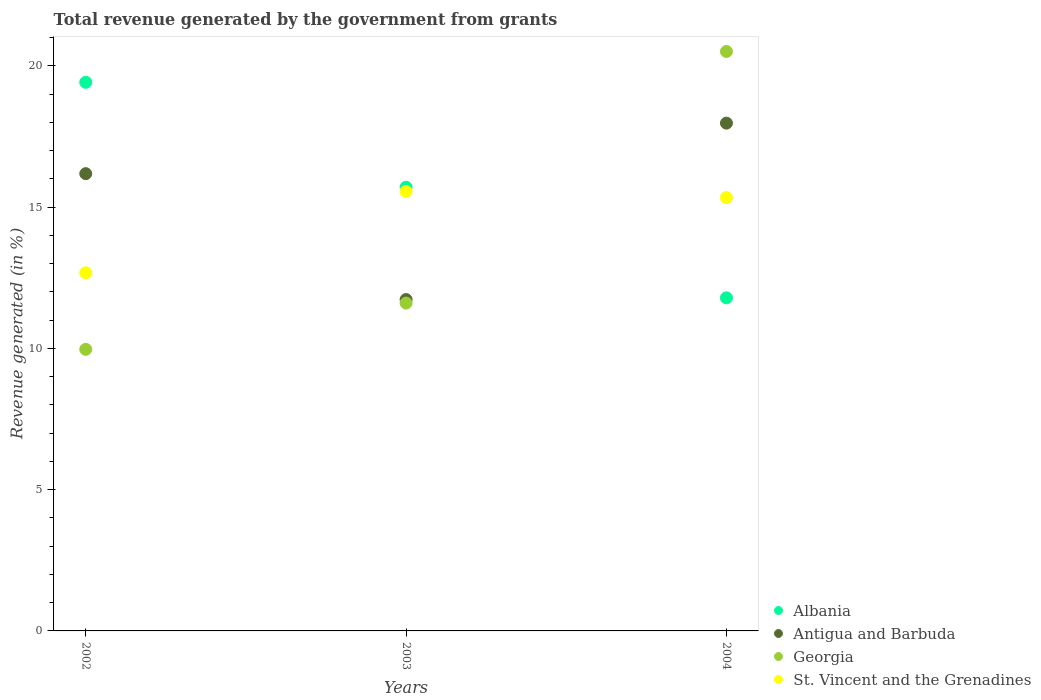How many different coloured dotlines are there?
Provide a short and direct response. 4. What is the total revenue generated in St. Vincent and the Grenadines in 2002?
Provide a short and direct response. 12.68. Across all years, what is the maximum total revenue generated in Antigua and Barbuda?
Your response must be concise. 17.97. Across all years, what is the minimum total revenue generated in St. Vincent and the Grenadines?
Offer a very short reply. 12.68. What is the total total revenue generated in Antigua and Barbuda in the graph?
Your response must be concise. 45.88. What is the difference between the total revenue generated in Albania in 2003 and that in 2004?
Keep it short and to the point. 3.91. What is the difference between the total revenue generated in Albania in 2004 and the total revenue generated in St. Vincent and the Grenadines in 2002?
Keep it short and to the point. -0.89. What is the average total revenue generated in St. Vincent and the Grenadines per year?
Offer a terse response. 14.52. In the year 2004, what is the difference between the total revenue generated in Georgia and total revenue generated in Antigua and Barbuda?
Offer a terse response. 2.54. What is the ratio of the total revenue generated in Georgia in 2002 to that in 2003?
Your answer should be very brief. 0.86. Is the difference between the total revenue generated in Georgia in 2003 and 2004 greater than the difference between the total revenue generated in Antigua and Barbuda in 2003 and 2004?
Keep it short and to the point. No. What is the difference between the highest and the second highest total revenue generated in Antigua and Barbuda?
Your answer should be very brief. 1.79. What is the difference between the highest and the lowest total revenue generated in St. Vincent and the Grenadines?
Offer a terse response. 2.88. Is the sum of the total revenue generated in Albania in 2003 and 2004 greater than the maximum total revenue generated in Antigua and Barbuda across all years?
Make the answer very short. Yes. Is it the case that in every year, the sum of the total revenue generated in Antigua and Barbuda and total revenue generated in St. Vincent and the Grenadines  is greater than the sum of total revenue generated in Georgia and total revenue generated in Albania?
Offer a terse response. No. Is it the case that in every year, the sum of the total revenue generated in St. Vincent and the Grenadines and total revenue generated in Antigua and Barbuda  is greater than the total revenue generated in Albania?
Make the answer very short. Yes. Does the total revenue generated in St. Vincent and the Grenadines monotonically increase over the years?
Provide a succinct answer. No. How many years are there in the graph?
Your answer should be compact. 3. What is the difference between two consecutive major ticks on the Y-axis?
Provide a succinct answer. 5. Are the values on the major ticks of Y-axis written in scientific E-notation?
Offer a terse response. No. Where does the legend appear in the graph?
Keep it short and to the point. Bottom right. How many legend labels are there?
Your answer should be compact. 4. How are the legend labels stacked?
Provide a short and direct response. Vertical. What is the title of the graph?
Your answer should be very brief. Total revenue generated by the government from grants. Does "Syrian Arab Republic" appear as one of the legend labels in the graph?
Give a very brief answer. No. What is the label or title of the X-axis?
Keep it short and to the point. Years. What is the label or title of the Y-axis?
Provide a short and direct response. Revenue generated (in %). What is the Revenue generated (in %) of Albania in 2002?
Offer a very short reply. 19.42. What is the Revenue generated (in %) of Antigua and Barbuda in 2002?
Offer a terse response. 16.18. What is the Revenue generated (in %) of Georgia in 2002?
Provide a short and direct response. 9.97. What is the Revenue generated (in %) of St. Vincent and the Grenadines in 2002?
Your answer should be compact. 12.68. What is the Revenue generated (in %) in Albania in 2003?
Provide a short and direct response. 15.7. What is the Revenue generated (in %) in Antigua and Barbuda in 2003?
Offer a terse response. 11.73. What is the Revenue generated (in %) in Georgia in 2003?
Give a very brief answer. 11.6. What is the Revenue generated (in %) of St. Vincent and the Grenadines in 2003?
Give a very brief answer. 15.56. What is the Revenue generated (in %) of Albania in 2004?
Make the answer very short. 11.79. What is the Revenue generated (in %) in Antigua and Barbuda in 2004?
Give a very brief answer. 17.97. What is the Revenue generated (in %) in Georgia in 2004?
Offer a terse response. 20.51. What is the Revenue generated (in %) in St. Vincent and the Grenadines in 2004?
Provide a short and direct response. 15.34. Across all years, what is the maximum Revenue generated (in %) in Albania?
Give a very brief answer. 19.42. Across all years, what is the maximum Revenue generated (in %) in Antigua and Barbuda?
Ensure brevity in your answer.  17.97. Across all years, what is the maximum Revenue generated (in %) in Georgia?
Provide a short and direct response. 20.51. Across all years, what is the maximum Revenue generated (in %) in St. Vincent and the Grenadines?
Offer a very short reply. 15.56. Across all years, what is the minimum Revenue generated (in %) of Albania?
Give a very brief answer. 11.79. Across all years, what is the minimum Revenue generated (in %) of Antigua and Barbuda?
Offer a terse response. 11.73. Across all years, what is the minimum Revenue generated (in %) in Georgia?
Offer a terse response. 9.97. Across all years, what is the minimum Revenue generated (in %) of St. Vincent and the Grenadines?
Your answer should be very brief. 12.68. What is the total Revenue generated (in %) of Albania in the graph?
Your answer should be very brief. 46.91. What is the total Revenue generated (in %) in Antigua and Barbuda in the graph?
Ensure brevity in your answer.  45.88. What is the total Revenue generated (in %) of Georgia in the graph?
Ensure brevity in your answer.  42.08. What is the total Revenue generated (in %) in St. Vincent and the Grenadines in the graph?
Give a very brief answer. 43.57. What is the difference between the Revenue generated (in %) of Albania in 2002 and that in 2003?
Keep it short and to the point. 3.72. What is the difference between the Revenue generated (in %) of Antigua and Barbuda in 2002 and that in 2003?
Give a very brief answer. 4.46. What is the difference between the Revenue generated (in %) in Georgia in 2002 and that in 2003?
Ensure brevity in your answer.  -1.64. What is the difference between the Revenue generated (in %) in St. Vincent and the Grenadines in 2002 and that in 2003?
Offer a very short reply. -2.88. What is the difference between the Revenue generated (in %) in Albania in 2002 and that in 2004?
Provide a short and direct response. 7.63. What is the difference between the Revenue generated (in %) in Antigua and Barbuda in 2002 and that in 2004?
Offer a terse response. -1.79. What is the difference between the Revenue generated (in %) of Georgia in 2002 and that in 2004?
Give a very brief answer. -10.54. What is the difference between the Revenue generated (in %) in St. Vincent and the Grenadines in 2002 and that in 2004?
Make the answer very short. -2.66. What is the difference between the Revenue generated (in %) in Albania in 2003 and that in 2004?
Your answer should be compact. 3.91. What is the difference between the Revenue generated (in %) in Antigua and Barbuda in 2003 and that in 2004?
Offer a very short reply. -6.24. What is the difference between the Revenue generated (in %) in Georgia in 2003 and that in 2004?
Your answer should be compact. -8.9. What is the difference between the Revenue generated (in %) in St. Vincent and the Grenadines in 2003 and that in 2004?
Your response must be concise. 0.22. What is the difference between the Revenue generated (in %) of Albania in 2002 and the Revenue generated (in %) of Antigua and Barbuda in 2003?
Give a very brief answer. 7.69. What is the difference between the Revenue generated (in %) of Albania in 2002 and the Revenue generated (in %) of Georgia in 2003?
Make the answer very short. 7.81. What is the difference between the Revenue generated (in %) of Albania in 2002 and the Revenue generated (in %) of St. Vincent and the Grenadines in 2003?
Offer a terse response. 3.86. What is the difference between the Revenue generated (in %) in Antigua and Barbuda in 2002 and the Revenue generated (in %) in Georgia in 2003?
Your response must be concise. 4.58. What is the difference between the Revenue generated (in %) of Antigua and Barbuda in 2002 and the Revenue generated (in %) of St. Vincent and the Grenadines in 2003?
Your answer should be compact. 0.63. What is the difference between the Revenue generated (in %) of Georgia in 2002 and the Revenue generated (in %) of St. Vincent and the Grenadines in 2003?
Provide a short and direct response. -5.59. What is the difference between the Revenue generated (in %) of Albania in 2002 and the Revenue generated (in %) of Antigua and Barbuda in 2004?
Offer a very short reply. 1.45. What is the difference between the Revenue generated (in %) of Albania in 2002 and the Revenue generated (in %) of Georgia in 2004?
Make the answer very short. -1.09. What is the difference between the Revenue generated (in %) of Albania in 2002 and the Revenue generated (in %) of St. Vincent and the Grenadines in 2004?
Your response must be concise. 4.08. What is the difference between the Revenue generated (in %) of Antigua and Barbuda in 2002 and the Revenue generated (in %) of Georgia in 2004?
Provide a short and direct response. -4.32. What is the difference between the Revenue generated (in %) of Antigua and Barbuda in 2002 and the Revenue generated (in %) of St. Vincent and the Grenadines in 2004?
Your response must be concise. 0.85. What is the difference between the Revenue generated (in %) of Georgia in 2002 and the Revenue generated (in %) of St. Vincent and the Grenadines in 2004?
Provide a short and direct response. -5.37. What is the difference between the Revenue generated (in %) of Albania in 2003 and the Revenue generated (in %) of Antigua and Barbuda in 2004?
Your response must be concise. -2.27. What is the difference between the Revenue generated (in %) in Albania in 2003 and the Revenue generated (in %) in Georgia in 2004?
Give a very brief answer. -4.81. What is the difference between the Revenue generated (in %) in Albania in 2003 and the Revenue generated (in %) in St. Vincent and the Grenadines in 2004?
Make the answer very short. 0.36. What is the difference between the Revenue generated (in %) in Antigua and Barbuda in 2003 and the Revenue generated (in %) in Georgia in 2004?
Your answer should be compact. -8.78. What is the difference between the Revenue generated (in %) of Antigua and Barbuda in 2003 and the Revenue generated (in %) of St. Vincent and the Grenadines in 2004?
Keep it short and to the point. -3.61. What is the difference between the Revenue generated (in %) in Georgia in 2003 and the Revenue generated (in %) in St. Vincent and the Grenadines in 2004?
Provide a succinct answer. -3.73. What is the average Revenue generated (in %) of Albania per year?
Offer a very short reply. 15.64. What is the average Revenue generated (in %) in Antigua and Barbuda per year?
Offer a terse response. 15.29. What is the average Revenue generated (in %) of Georgia per year?
Make the answer very short. 14.03. What is the average Revenue generated (in %) of St. Vincent and the Grenadines per year?
Provide a short and direct response. 14.52. In the year 2002, what is the difference between the Revenue generated (in %) in Albania and Revenue generated (in %) in Antigua and Barbuda?
Keep it short and to the point. 3.23. In the year 2002, what is the difference between the Revenue generated (in %) of Albania and Revenue generated (in %) of Georgia?
Give a very brief answer. 9.45. In the year 2002, what is the difference between the Revenue generated (in %) of Albania and Revenue generated (in %) of St. Vincent and the Grenadines?
Provide a succinct answer. 6.74. In the year 2002, what is the difference between the Revenue generated (in %) of Antigua and Barbuda and Revenue generated (in %) of Georgia?
Your response must be concise. 6.22. In the year 2002, what is the difference between the Revenue generated (in %) of Antigua and Barbuda and Revenue generated (in %) of St. Vincent and the Grenadines?
Provide a short and direct response. 3.51. In the year 2002, what is the difference between the Revenue generated (in %) in Georgia and Revenue generated (in %) in St. Vincent and the Grenadines?
Give a very brief answer. -2.71. In the year 2003, what is the difference between the Revenue generated (in %) in Albania and Revenue generated (in %) in Antigua and Barbuda?
Your answer should be very brief. 3.97. In the year 2003, what is the difference between the Revenue generated (in %) in Albania and Revenue generated (in %) in Georgia?
Provide a succinct answer. 4.1. In the year 2003, what is the difference between the Revenue generated (in %) of Albania and Revenue generated (in %) of St. Vincent and the Grenadines?
Provide a succinct answer. 0.15. In the year 2003, what is the difference between the Revenue generated (in %) of Antigua and Barbuda and Revenue generated (in %) of Georgia?
Your answer should be very brief. 0.12. In the year 2003, what is the difference between the Revenue generated (in %) in Antigua and Barbuda and Revenue generated (in %) in St. Vincent and the Grenadines?
Keep it short and to the point. -3.83. In the year 2003, what is the difference between the Revenue generated (in %) of Georgia and Revenue generated (in %) of St. Vincent and the Grenadines?
Ensure brevity in your answer.  -3.95. In the year 2004, what is the difference between the Revenue generated (in %) of Albania and Revenue generated (in %) of Antigua and Barbuda?
Provide a short and direct response. -6.18. In the year 2004, what is the difference between the Revenue generated (in %) in Albania and Revenue generated (in %) in Georgia?
Your answer should be compact. -8.72. In the year 2004, what is the difference between the Revenue generated (in %) in Albania and Revenue generated (in %) in St. Vincent and the Grenadines?
Offer a terse response. -3.55. In the year 2004, what is the difference between the Revenue generated (in %) of Antigua and Barbuda and Revenue generated (in %) of Georgia?
Your answer should be very brief. -2.54. In the year 2004, what is the difference between the Revenue generated (in %) of Antigua and Barbuda and Revenue generated (in %) of St. Vincent and the Grenadines?
Provide a short and direct response. 2.63. In the year 2004, what is the difference between the Revenue generated (in %) in Georgia and Revenue generated (in %) in St. Vincent and the Grenadines?
Your answer should be very brief. 5.17. What is the ratio of the Revenue generated (in %) in Albania in 2002 to that in 2003?
Offer a terse response. 1.24. What is the ratio of the Revenue generated (in %) of Antigua and Barbuda in 2002 to that in 2003?
Ensure brevity in your answer.  1.38. What is the ratio of the Revenue generated (in %) of Georgia in 2002 to that in 2003?
Your answer should be compact. 0.86. What is the ratio of the Revenue generated (in %) of St. Vincent and the Grenadines in 2002 to that in 2003?
Offer a very short reply. 0.81. What is the ratio of the Revenue generated (in %) of Albania in 2002 to that in 2004?
Offer a very short reply. 1.65. What is the ratio of the Revenue generated (in %) in Antigua and Barbuda in 2002 to that in 2004?
Give a very brief answer. 0.9. What is the ratio of the Revenue generated (in %) of Georgia in 2002 to that in 2004?
Offer a very short reply. 0.49. What is the ratio of the Revenue generated (in %) of St. Vincent and the Grenadines in 2002 to that in 2004?
Your answer should be compact. 0.83. What is the ratio of the Revenue generated (in %) in Albania in 2003 to that in 2004?
Your answer should be very brief. 1.33. What is the ratio of the Revenue generated (in %) in Antigua and Barbuda in 2003 to that in 2004?
Your answer should be very brief. 0.65. What is the ratio of the Revenue generated (in %) of Georgia in 2003 to that in 2004?
Your answer should be very brief. 0.57. What is the ratio of the Revenue generated (in %) of St. Vincent and the Grenadines in 2003 to that in 2004?
Provide a short and direct response. 1.01. What is the difference between the highest and the second highest Revenue generated (in %) in Albania?
Provide a short and direct response. 3.72. What is the difference between the highest and the second highest Revenue generated (in %) of Antigua and Barbuda?
Give a very brief answer. 1.79. What is the difference between the highest and the second highest Revenue generated (in %) in Georgia?
Your answer should be compact. 8.9. What is the difference between the highest and the second highest Revenue generated (in %) in St. Vincent and the Grenadines?
Offer a very short reply. 0.22. What is the difference between the highest and the lowest Revenue generated (in %) in Albania?
Keep it short and to the point. 7.63. What is the difference between the highest and the lowest Revenue generated (in %) in Antigua and Barbuda?
Keep it short and to the point. 6.24. What is the difference between the highest and the lowest Revenue generated (in %) in Georgia?
Make the answer very short. 10.54. What is the difference between the highest and the lowest Revenue generated (in %) of St. Vincent and the Grenadines?
Your answer should be very brief. 2.88. 